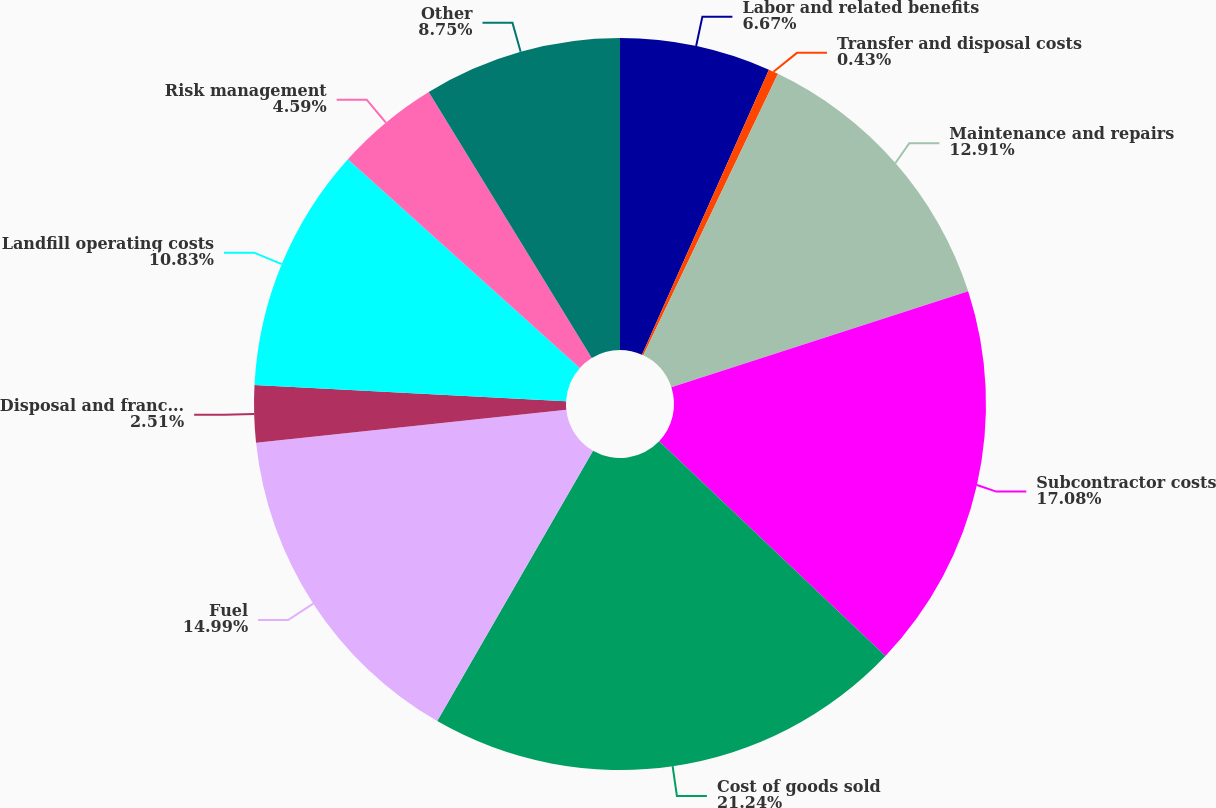<chart> <loc_0><loc_0><loc_500><loc_500><pie_chart><fcel>Labor and related benefits<fcel>Transfer and disposal costs<fcel>Maintenance and repairs<fcel>Subcontractor costs<fcel>Cost of goods sold<fcel>Fuel<fcel>Disposal and franchise fees<fcel>Landfill operating costs<fcel>Risk management<fcel>Other<nl><fcel>6.67%<fcel>0.43%<fcel>12.91%<fcel>17.07%<fcel>21.23%<fcel>14.99%<fcel>2.51%<fcel>10.83%<fcel>4.59%<fcel>8.75%<nl></chart> 